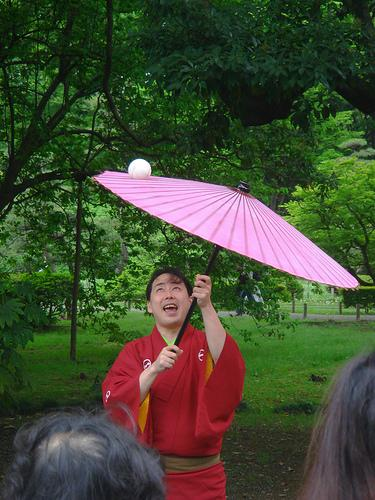Why is the ball on the parasol? Please explain your reasoning. is trick. The man is balancing the ball and has a crowd. 